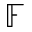Convert formula to latex. <formula><loc_0><loc_0><loc_500><loc_500>\mathbb { F }</formula> 